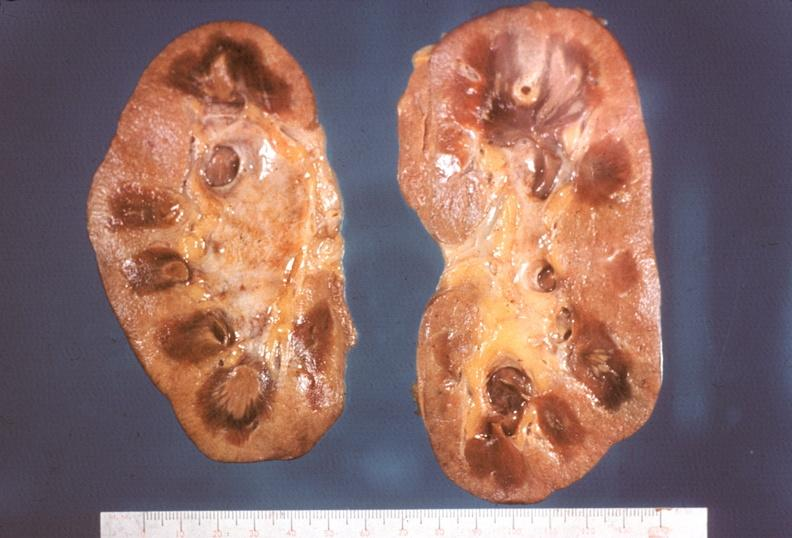what does this image show?
Answer the question using a single word or phrase. Kidney 